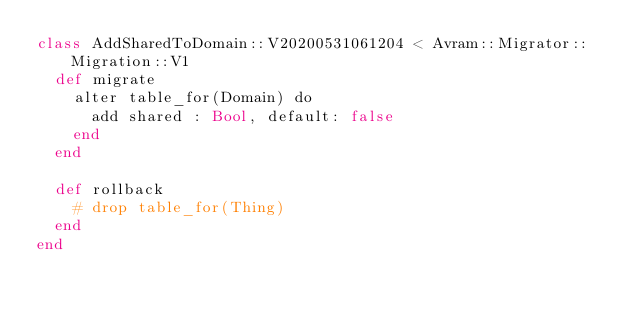Convert code to text. <code><loc_0><loc_0><loc_500><loc_500><_Crystal_>class AddSharedToDomain::V20200531061204 < Avram::Migrator::Migration::V1
  def migrate
    alter table_for(Domain) do
      add shared : Bool, default: false
    end
  end

  def rollback
    # drop table_for(Thing)
  end
end
</code> 